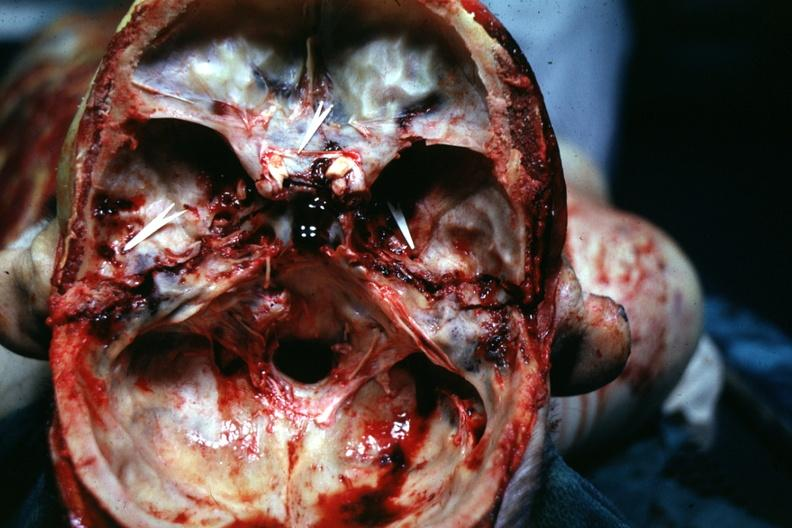what is present?
Answer the question using a single word or phrase. Basilar skull fracture 